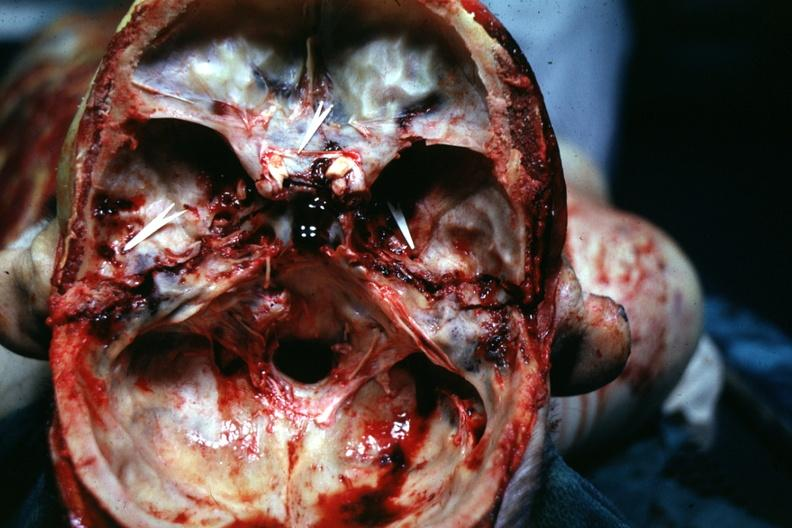what is present?
Answer the question using a single word or phrase. Basilar skull fracture 